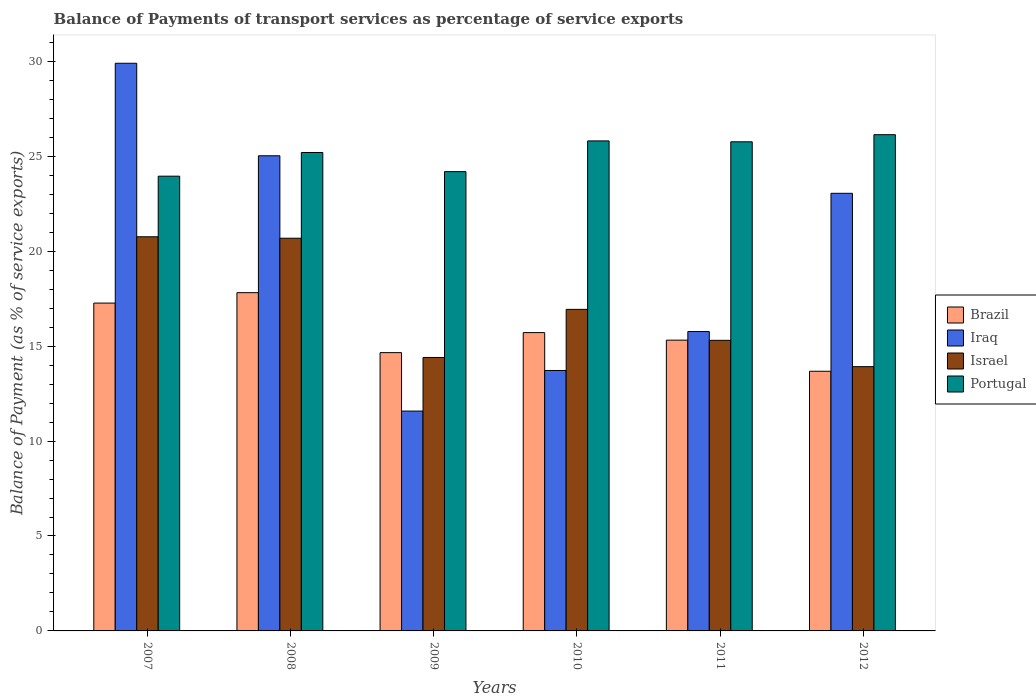Are the number of bars per tick equal to the number of legend labels?
Offer a terse response. Yes. What is the label of the 6th group of bars from the left?
Make the answer very short. 2012. What is the balance of payments of transport services in Portugal in 2008?
Offer a terse response. 25.2. Across all years, what is the maximum balance of payments of transport services in Portugal?
Provide a short and direct response. 26.14. Across all years, what is the minimum balance of payments of transport services in Portugal?
Provide a short and direct response. 23.95. In which year was the balance of payments of transport services in Brazil maximum?
Offer a very short reply. 2008. In which year was the balance of payments of transport services in Brazil minimum?
Your answer should be very brief. 2012. What is the total balance of payments of transport services in Brazil in the graph?
Your answer should be very brief. 94.45. What is the difference between the balance of payments of transport services in Portugal in 2009 and that in 2010?
Your answer should be very brief. -1.62. What is the difference between the balance of payments of transport services in Iraq in 2007 and the balance of payments of transport services in Israel in 2008?
Offer a terse response. 9.22. What is the average balance of payments of transport services in Israel per year?
Your response must be concise. 17. In the year 2007, what is the difference between the balance of payments of transport services in Iraq and balance of payments of transport services in Brazil?
Your answer should be very brief. 12.63. What is the ratio of the balance of payments of transport services in Brazil in 2009 to that in 2010?
Your answer should be very brief. 0.93. What is the difference between the highest and the second highest balance of payments of transport services in Brazil?
Your answer should be compact. 0.55. What is the difference between the highest and the lowest balance of payments of transport services in Brazil?
Your response must be concise. 4.14. Is the sum of the balance of payments of transport services in Israel in 2010 and 2012 greater than the maximum balance of payments of transport services in Portugal across all years?
Your answer should be compact. Yes. Is it the case that in every year, the sum of the balance of payments of transport services in Brazil and balance of payments of transport services in Israel is greater than the sum of balance of payments of transport services in Iraq and balance of payments of transport services in Portugal?
Your response must be concise. No. What does the 1st bar from the right in 2010 represents?
Keep it short and to the point. Portugal. Is it the case that in every year, the sum of the balance of payments of transport services in Iraq and balance of payments of transport services in Israel is greater than the balance of payments of transport services in Portugal?
Give a very brief answer. Yes. How many years are there in the graph?
Make the answer very short. 6. Does the graph contain any zero values?
Offer a very short reply. No. What is the title of the graph?
Make the answer very short. Balance of Payments of transport services as percentage of service exports. What is the label or title of the Y-axis?
Offer a terse response. Balance of Payment (as % of service exports). What is the Balance of Payment (as % of service exports) of Brazil in 2007?
Ensure brevity in your answer.  17.27. What is the Balance of Payment (as % of service exports) of Iraq in 2007?
Make the answer very short. 29.9. What is the Balance of Payment (as % of service exports) in Israel in 2007?
Your response must be concise. 20.76. What is the Balance of Payment (as % of service exports) of Portugal in 2007?
Your answer should be very brief. 23.95. What is the Balance of Payment (as % of service exports) in Brazil in 2008?
Offer a terse response. 17.82. What is the Balance of Payment (as % of service exports) of Iraq in 2008?
Make the answer very short. 25.03. What is the Balance of Payment (as % of service exports) of Israel in 2008?
Ensure brevity in your answer.  20.68. What is the Balance of Payment (as % of service exports) in Portugal in 2008?
Your answer should be compact. 25.2. What is the Balance of Payment (as % of service exports) of Brazil in 2009?
Provide a succinct answer. 14.66. What is the Balance of Payment (as % of service exports) of Iraq in 2009?
Offer a very short reply. 11.58. What is the Balance of Payment (as % of service exports) in Israel in 2009?
Provide a short and direct response. 14.4. What is the Balance of Payment (as % of service exports) in Portugal in 2009?
Keep it short and to the point. 24.19. What is the Balance of Payment (as % of service exports) in Brazil in 2010?
Keep it short and to the point. 15.71. What is the Balance of Payment (as % of service exports) in Iraq in 2010?
Your answer should be compact. 13.72. What is the Balance of Payment (as % of service exports) of Israel in 2010?
Offer a very short reply. 16.94. What is the Balance of Payment (as % of service exports) of Portugal in 2010?
Offer a very short reply. 25.81. What is the Balance of Payment (as % of service exports) of Brazil in 2011?
Offer a terse response. 15.32. What is the Balance of Payment (as % of service exports) in Iraq in 2011?
Keep it short and to the point. 15.77. What is the Balance of Payment (as % of service exports) of Israel in 2011?
Provide a succinct answer. 15.31. What is the Balance of Payment (as % of service exports) in Portugal in 2011?
Ensure brevity in your answer.  25.76. What is the Balance of Payment (as % of service exports) of Brazil in 2012?
Provide a succinct answer. 13.68. What is the Balance of Payment (as % of service exports) in Iraq in 2012?
Make the answer very short. 23.05. What is the Balance of Payment (as % of service exports) of Israel in 2012?
Offer a very short reply. 13.92. What is the Balance of Payment (as % of service exports) of Portugal in 2012?
Make the answer very short. 26.14. Across all years, what is the maximum Balance of Payment (as % of service exports) of Brazil?
Provide a short and direct response. 17.82. Across all years, what is the maximum Balance of Payment (as % of service exports) in Iraq?
Provide a succinct answer. 29.9. Across all years, what is the maximum Balance of Payment (as % of service exports) in Israel?
Offer a terse response. 20.76. Across all years, what is the maximum Balance of Payment (as % of service exports) in Portugal?
Ensure brevity in your answer.  26.14. Across all years, what is the minimum Balance of Payment (as % of service exports) in Brazil?
Keep it short and to the point. 13.68. Across all years, what is the minimum Balance of Payment (as % of service exports) in Iraq?
Your response must be concise. 11.58. Across all years, what is the minimum Balance of Payment (as % of service exports) of Israel?
Offer a terse response. 13.92. Across all years, what is the minimum Balance of Payment (as % of service exports) in Portugal?
Provide a succinct answer. 23.95. What is the total Balance of Payment (as % of service exports) of Brazil in the graph?
Provide a succinct answer. 94.45. What is the total Balance of Payment (as % of service exports) of Iraq in the graph?
Ensure brevity in your answer.  119.04. What is the total Balance of Payment (as % of service exports) of Israel in the graph?
Provide a succinct answer. 102.01. What is the total Balance of Payment (as % of service exports) of Portugal in the graph?
Ensure brevity in your answer.  151.05. What is the difference between the Balance of Payment (as % of service exports) in Brazil in 2007 and that in 2008?
Your answer should be compact. -0.55. What is the difference between the Balance of Payment (as % of service exports) in Iraq in 2007 and that in 2008?
Your response must be concise. 4.87. What is the difference between the Balance of Payment (as % of service exports) of Israel in 2007 and that in 2008?
Provide a succinct answer. 0.08. What is the difference between the Balance of Payment (as % of service exports) of Portugal in 2007 and that in 2008?
Ensure brevity in your answer.  -1.25. What is the difference between the Balance of Payment (as % of service exports) in Brazil in 2007 and that in 2009?
Provide a succinct answer. 2.61. What is the difference between the Balance of Payment (as % of service exports) of Iraq in 2007 and that in 2009?
Your response must be concise. 18.32. What is the difference between the Balance of Payment (as % of service exports) in Israel in 2007 and that in 2009?
Provide a succinct answer. 6.36. What is the difference between the Balance of Payment (as % of service exports) of Portugal in 2007 and that in 2009?
Provide a short and direct response. -0.24. What is the difference between the Balance of Payment (as % of service exports) of Brazil in 2007 and that in 2010?
Provide a short and direct response. 1.56. What is the difference between the Balance of Payment (as % of service exports) in Iraq in 2007 and that in 2010?
Offer a terse response. 16.18. What is the difference between the Balance of Payment (as % of service exports) of Israel in 2007 and that in 2010?
Give a very brief answer. 3.82. What is the difference between the Balance of Payment (as % of service exports) of Portugal in 2007 and that in 2010?
Ensure brevity in your answer.  -1.86. What is the difference between the Balance of Payment (as % of service exports) of Brazil in 2007 and that in 2011?
Provide a succinct answer. 1.95. What is the difference between the Balance of Payment (as % of service exports) in Iraq in 2007 and that in 2011?
Provide a short and direct response. 14.13. What is the difference between the Balance of Payment (as % of service exports) in Israel in 2007 and that in 2011?
Make the answer very short. 5.45. What is the difference between the Balance of Payment (as % of service exports) in Portugal in 2007 and that in 2011?
Ensure brevity in your answer.  -1.81. What is the difference between the Balance of Payment (as % of service exports) in Brazil in 2007 and that in 2012?
Your response must be concise. 3.59. What is the difference between the Balance of Payment (as % of service exports) in Iraq in 2007 and that in 2012?
Offer a very short reply. 6.85. What is the difference between the Balance of Payment (as % of service exports) in Israel in 2007 and that in 2012?
Give a very brief answer. 6.84. What is the difference between the Balance of Payment (as % of service exports) in Portugal in 2007 and that in 2012?
Your answer should be compact. -2.19. What is the difference between the Balance of Payment (as % of service exports) in Brazil in 2008 and that in 2009?
Offer a terse response. 3.16. What is the difference between the Balance of Payment (as % of service exports) in Iraq in 2008 and that in 2009?
Make the answer very short. 13.45. What is the difference between the Balance of Payment (as % of service exports) in Israel in 2008 and that in 2009?
Offer a very short reply. 6.28. What is the difference between the Balance of Payment (as % of service exports) in Portugal in 2008 and that in 2009?
Offer a very short reply. 1.01. What is the difference between the Balance of Payment (as % of service exports) of Brazil in 2008 and that in 2010?
Keep it short and to the point. 2.1. What is the difference between the Balance of Payment (as % of service exports) of Iraq in 2008 and that in 2010?
Make the answer very short. 11.31. What is the difference between the Balance of Payment (as % of service exports) in Israel in 2008 and that in 2010?
Ensure brevity in your answer.  3.75. What is the difference between the Balance of Payment (as % of service exports) of Portugal in 2008 and that in 2010?
Your answer should be very brief. -0.61. What is the difference between the Balance of Payment (as % of service exports) in Brazil in 2008 and that in 2011?
Provide a short and direct response. 2.5. What is the difference between the Balance of Payment (as % of service exports) of Iraq in 2008 and that in 2011?
Your answer should be compact. 9.26. What is the difference between the Balance of Payment (as % of service exports) of Israel in 2008 and that in 2011?
Offer a very short reply. 5.38. What is the difference between the Balance of Payment (as % of service exports) in Portugal in 2008 and that in 2011?
Ensure brevity in your answer.  -0.56. What is the difference between the Balance of Payment (as % of service exports) in Brazil in 2008 and that in 2012?
Make the answer very short. 4.14. What is the difference between the Balance of Payment (as % of service exports) of Iraq in 2008 and that in 2012?
Offer a terse response. 1.98. What is the difference between the Balance of Payment (as % of service exports) in Israel in 2008 and that in 2012?
Keep it short and to the point. 6.76. What is the difference between the Balance of Payment (as % of service exports) of Portugal in 2008 and that in 2012?
Your response must be concise. -0.94. What is the difference between the Balance of Payment (as % of service exports) of Brazil in 2009 and that in 2010?
Make the answer very short. -1.05. What is the difference between the Balance of Payment (as % of service exports) in Iraq in 2009 and that in 2010?
Keep it short and to the point. -2.14. What is the difference between the Balance of Payment (as % of service exports) in Israel in 2009 and that in 2010?
Your answer should be compact. -2.53. What is the difference between the Balance of Payment (as % of service exports) of Portugal in 2009 and that in 2010?
Provide a short and direct response. -1.62. What is the difference between the Balance of Payment (as % of service exports) of Brazil in 2009 and that in 2011?
Keep it short and to the point. -0.66. What is the difference between the Balance of Payment (as % of service exports) in Iraq in 2009 and that in 2011?
Make the answer very short. -4.19. What is the difference between the Balance of Payment (as % of service exports) in Israel in 2009 and that in 2011?
Your answer should be very brief. -0.9. What is the difference between the Balance of Payment (as % of service exports) of Portugal in 2009 and that in 2011?
Your answer should be very brief. -1.57. What is the difference between the Balance of Payment (as % of service exports) of Brazil in 2009 and that in 2012?
Make the answer very short. 0.98. What is the difference between the Balance of Payment (as % of service exports) of Iraq in 2009 and that in 2012?
Ensure brevity in your answer.  -11.47. What is the difference between the Balance of Payment (as % of service exports) of Israel in 2009 and that in 2012?
Your response must be concise. 0.48. What is the difference between the Balance of Payment (as % of service exports) of Portugal in 2009 and that in 2012?
Your answer should be compact. -1.95. What is the difference between the Balance of Payment (as % of service exports) of Brazil in 2010 and that in 2011?
Keep it short and to the point. 0.4. What is the difference between the Balance of Payment (as % of service exports) of Iraq in 2010 and that in 2011?
Your response must be concise. -2.05. What is the difference between the Balance of Payment (as % of service exports) in Israel in 2010 and that in 2011?
Ensure brevity in your answer.  1.63. What is the difference between the Balance of Payment (as % of service exports) in Portugal in 2010 and that in 2011?
Offer a very short reply. 0.05. What is the difference between the Balance of Payment (as % of service exports) in Brazil in 2010 and that in 2012?
Your response must be concise. 2.04. What is the difference between the Balance of Payment (as % of service exports) in Iraq in 2010 and that in 2012?
Offer a very short reply. -9.33. What is the difference between the Balance of Payment (as % of service exports) in Israel in 2010 and that in 2012?
Offer a terse response. 3.02. What is the difference between the Balance of Payment (as % of service exports) in Portugal in 2010 and that in 2012?
Keep it short and to the point. -0.33. What is the difference between the Balance of Payment (as % of service exports) of Brazil in 2011 and that in 2012?
Offer a terse response. 1.64. What is the difference between the Balance of Payment (as % of service exports) in Iraq in 2011 and that in 2012?
Give a very brief answer. -7.28. What is the difference between the Balance of Payment (as % of service exports) of Israel in 2011 and that in 2012?
Make the answer very short. 1.39. What is the difference between the Balance of Payment (as % of service exports) in Portugal in 2011 and that in 2012?
Your answer should be compact. -0.37. What is the difference between the Balance of Payment (as % of service exports) in Brazil in 2007 and the Balance of Payment (as % of service exports) in Iraq in 2008?
Offer a terse response. -7.76. What is the difference between the Balance of Payment (as % of service exports) of Brazil in 2007 and the Balance of Payment (as % of service exports) of Israel in 2008?
Give a very brief answer. -3.42. What is the difference between the Balance of Payment (as % of service exports) of Brazil in 2007 and the Balance of Payment (as % of service exports) of Portugal in 2008?
Your answer should be compact. -7.93. What is the difference between the Balance of Payment (as % of service exports) of Iraq in 2007 and the Balance of Payment (as % of service exports) of Israel in 2008?
Provide a succinct answer. 9.22. What is the difference between the Balance of Payment (as % of service exports) in Iraq in 2007 and the Balance of Payment (as % of service exports) in Portugal in 2008?
Give a very brief answer. 4.7. What is the difference between the Balance of Payment (as % of service exports) in Israel in 2007 and the Balance of Payment (as % of service exports) in Portugal in 2008?
Make the answer very short. -4.44. What is the difference between the Balance of Payment (as % of service exports) in Brazil in 2007 and the Balance of Payment (as % of service exports) in Iraq in 2009?
Your response must be concise. 5.69. What is the difference between the Balance of Payment (as % of service exports) of Brazil in 2007 and the Balance of Payment (as % of service exports) of Israel in 2009?
Provide a short and direct response. 2.87. What is the difference between the Balance of Payment (as % of service exports) of Brazil in 2007 and the Balance of Payment (as % of service exports) of Portugal in 2009?
Provide a succinct answer. -6.92. What is the difference between the Balance of Payment (as % of service exports) of Iraq in 2007 and the Balance of Payment (as % of service exports) of Israel in 2009?
Your answer should be very brief. 15.5. What is the difference between the Balance of Payment (as % of service exports) of Iraq in 2007 and the Balance of Payment (as % of service exports) of Portugal in 2009?
Give a very brief answer. 5.71. What is the difference between the Balance of Payment (as % of service exports) of Israel in 2007 and the Balance of Payment (as % of service exports) of Portugal in 2009?
Offer a terse response. -3.43. What is the difference between the Balance of Payment (as % of service exports) in Brazil in 2007 and the Balance of Payment (as % of service exports) in Iraq in 2010?
Your response must be concise. 3.55. What is the difference between the Balance of Payment (as % of service exports) of Brazil in 2007 and the Balance of Payment (as % of service exports) of Israel in 2010?
Your answer should be very brief. 0.33. What is the difference between the Balance of Payment (as % of service exports) of Brazil in 2007 and the Balance of Payment (as % of service exports) of Portugal in 2010?
Ensure brevity in your answer.  -8.54. What is the difference between the Balance of Payment (as % of service exports) of Iraq in 2007 and the Balance of Payment (as % of service exports) of Israel in 2010?
Keep it short and to the point. 12.96. What is the difference between the Balance of Payment (as % of service exports) of Iraq in 2007 and the Balance of Payment (as % of service exports) of Portugal in 2010?
Provide a short and direct response. 4.09. What is the difference between the Balance of Payment (as % of service exports) of Israel in 2007 and the Balance of Payment (as % of service exports) of Portugal in 2010?
Offer a very short reply. -5.05. What is the difference between the Balance of Payment (as % of service exports) of Brazil in 2007 and the Balance of Payment (as % of service exports) of Iraq in 2011?
Your answer should be very brief. 1.5. What is the difference between the Balance of Payment (as % of service exports) of Brazil in 2007 and the Balance of Payment (as % of service exports) of Israel in 2011?
Offer a very short reply. 1.96. What is the difference between the Balance of Payment (as % of service exports) of Brazil in 2007 and the Balance of Payment (as % of service exports) of Portugal in 2011?
Your answer should be very brief. -8.49. What is the difference between the Balance of Payment (as % of service exports) of Iraq in 2007 and the Balance of Payment (as % of service exports) of Israel in 2011?
Provide a short and direct response. 14.59. What is the difference between the Balance of Payment (as % of service exports) in Iraq in 2007 and the Balance of Payment (as % of service exports) in Portugal in 2011?
Provide a succinct answer. 4.14. What is the difference between the Balance of Payment (as % of service exports) in Israel in 2007 and the Balance of Payment (as % of service exports) in Portugal in 2011?
Provide a succinct answer. -5. What is the difference between the Balance of Payment (as % of service exports) in Brazil in 2007 and the Balance of Payment (as % of service exports) in Iraq in 2012?
Your answer should be very brief. -5.78. What is the difference between the Balance of Payment (as % of service exports) of Brazil in 2007 and the Balance of Payment (as % of service exports) of Israel in 2012?
Provide a succinct answer. 3.35. What is the difference between the Balance of Payment (as % of service exports) in Brazil in 2007 and the Balance of Payment (as % of service exports) in Portugal in 2012?
Ensure brevity in your answer.  -8.87. What is the difference between the Balance of Payment (as % of service exports) of Iraq in 2007 and the Balance of Payment (as % of service exports) of Israel in 2012?
Ensure brevity in your answer.  15.98. What is the difference between the Balance of Payment (as % of service exports) in Iraq in 2007 and the Balance of Payment (as % of service exports) in Portugal in 2012?
Ensure brevity in your answer.  3.76. What is the difference between the Balance of Payment (as % of service exports) in Israel in 2007 and the Balance of Payment (as % of service exports) in Portugal in 2012?
Make the answer very short. -5.38. What is the difference between the Balance of Payment (as % of service exports) of Brazil in 2008 and the Balance of Payment (as % of service exports) of Iraq in 2009?
Give a very brief answer. 6.24. What is the difference between the Balance of Payment (as % of service exports) of Brazil in 2008 and the Balance of Payment (as % of service exports) of Israel in 2009?
Provide a succinct answer. 3.41. What is the difference between the Balance of Payment (as % of service exports) of Brazil in 2008 and the Balance of Payment (as % of service exports) of Portugal in 2009?
Keep it short and to the point. -6.37. What is the difference between the Balance of Payment (as % of service exports) of Iraq in 2008 and the Balance of Payment (as % of service exports) of Israel in 2009?
Provide a short and direct response. 10.62. What is the difference between the Balance of Payment (as % of service exports) in Iraq in 2008 and the Balance of Payment (as % of service exports) in Portugal in 2009?
Offer a very short reply. 0.84. What is the difference between the Balance of Payment (as % of service exports) in Israel in 2008 and the Balance of Payment (as % of service exports) in Portugal in 2009?
Provide a succinct answer. -3.51. What is the difference between the Balance of Payment (as % of service exports) of Brazil in 2008 and the Balance of Payment (as % of service exports) of Iraq in 2010?
Keep it short and to the point. 4.1. What is the difference between the Balance of Payment (as % of service exports) of Brazil in 2008 and the Balance of Payment (as % of service exports) of Israel in 2010?
Provide a succinct answer. 0.88. What is the difference between the Balance of Payment (as % of service exports) in Brazil in 2008 and the Balance of Payment (as % of service exports) in Portugal in 2010?
Offer a terse response. -7.99. What is the difference between the Balance of Payment (as % of service exports) of Iraq in 2008 and the Balance of Payment (as % of service exports) of Israel in 2010?
Provide a succinct answer. 8.09. What is the difference between the Balance of Payment (as % of service exports) of Iraq in 2008 and the Balance of Payment (as % of service exports) of Portugal in 2010?
Give a very brief answer. -0.78. What is the difference between the Balance of Payment (as % of service exports) in Israel in 2008 and the Balance of Payment (as % of service exports) in Portugal in 2010?
Give a very brief answer. -5.13. What is the difference between the Balance of Payment (as % of service exports) of Brazil in 2008 and the Balance of Payment (as % of service exports) of Iraq in 2011?
Provide a short and direct response. 2.05. What is the difference between the Balance of Payment (as % of service exports) in Brazil in 2008 and the Balance of Payment (as % of service exports) in Israel in 2011?
Ensure brevity in your answer.  2.51. What is the difference between the Balance of Payment (as % of service exports) in Brazil in 2008 and the Balance of Payment (as % of service exports) in Portugal in 2011?
Ensure brevity in your answer.  -7.95. What is the difference between the Balance of Payment (as % of service exports) of Iraq in 2008 and the Balance of Payment (as % of service exports) of Israel in 2011?
Offer a very short reply. 9.72. What is the difference between the Balance of Payment (as % of service exports) of Iraq in 2008 and the Balance of Payment (as % of service exports) of Portugal in 2011?
Your answer should be very brief. -0.74. What is the difference between the Balance of Payment (as % of service exports) in Israel in 2008 and the Balance of Payment (as % of service exports) in Portugal in 2011?
Your response must be concise. -5.08. What is the difference between the Balance of Payment (as % of service exports) in Brazil in 2008 and the Balance of Payment (as % of service exports) in Iraq in 2012?
Provide a succinct answer. -5.23. What is the difference between the Balance of Payment (as % of service exports) in Brazil in 2008 and the Balance of Payment (as % of service exports) in Israel in 2012?
Make the answer very short. 3.9. What is the difference between the Balance of Payment (as % of service exports) in Brazil in 2008 and the Balance of Payment (as % of service exports) in Portugal in 2012?
Your answer should be very brief. -8.32. What is the difference between the Balance of Payment (as % of service exports) in Iraq in 2008 and the Balance of Payment (as % of service exports) in Israel in 2012?
Offer a very short reply. 11.11. What is the difference between the Balance of Payment (as % of service exports) in Iraq in 2008 and the Balance of Payment (as % of service exports) in Portugal in 2012?
Offer a very short reply. -1.11. What is the difference between the Balance of Payment (as % of service exports) of Israel in 2008 and the Balance of Payment (as % of service exports) of Portugal in 2012?
Your answer should be very brief. -5.45. What is the difference between the Balance of Payment (as % of service exports) of Brazil in 2009 and the Balance of Payment (as % of service exports) of Iraq in 2010?
Give a very brief answer. 0.94. What is the difference between the Balance of Payment (as % of service exports) in Brazil in 2009 and the Balance of Payment (as % of service exports) in Israel in 2010?
Ensure brevity in your answer.  -2.28. What is the difference between the Balance of Payment (as % of service exports) in Brazil in 2009 and the Balance of Payment (as % of service exports) in Portugal in 2010?
Keep it short and to the point. -11.15. What is the difference between the Balance of Payment (as % of service exports) in Iraq in 2009 and the Balance of Payment (as % of service exports) in Israel in 2010?
Your response must be concise. -5.36. What is the difference between the Balance of Payment (as % of service exports) in Iraq in 2009 and the Balance of Payment (as % of service exports) in Portugal in 2010?
Ensure brevity in your answer.  -14.23. What is the difference between the Balance of Payment (as % of service exports) in Israel in 2009 and the Balance of Payment (as % of service exports) in Portugal in 2010?
Keep it short and to the point. -11.41. What is the difference between the Balance of Payment (as % of service exports) in Brazil in 2009 and the Balance of Payment (as % of service exports) in Iraq in 2011?
Give a very brief answer. -1.11. What is the difference between the Balance of Payment (as % of service exports) in Brazil in 2009 and the Balance of Payment (as % of service exports) in Israel in 2011?
Offer a very short reply. -0.65. What is the difference between the Balance of Payment (as % of service exports) in Brazil in 2009 and the Balance of Payment (as % of service exports) in Portugal in 2011?
Provide a short and direct response. -11.1. What is the difference between the Balance of Payment (as % of service exports) in Iraq in 2009 and the Balance of Payment (as % of service exports) in Israel in 2011?
Your response must be concise. -3.73. What is the difference between the Balance of Payment (as % of service exports) of Iraq in 2009 and the Balance of Payment (as % of service exports) of Portugal in 2011?
Offer a terse response. -14.18. What is the difference between the Balance of Payment (as % of service exports) of Israel in 2009 and the Balance of Payment (as % of service exports) of Portugal in 2011?
Ensure brevity in your answer.  -11.36. What is the difference between the Balance of Payment (as % of service exports) of Brazil in 2009 and the Balance of Payment (as % of service exports) of Iraq in 2012?
Offer a very short reply. -8.39. What is the difference between the Balance of Payment (as % of service exports) in Brazil in 2009 and the Balance of Payment (as % of service exports) in Israel in 2012?
Offer a terse response. 0.74. What is the difference between the Balance of Payment (as % of service exports) of Brazil in 2009 and the Balance of Payment (as % of service exports) of Portugal in 2012?
Your answer should be very brief. -11.48. What is the difference between the Balance of Payment (as % of service exports) in Iraq in 2009 and the Balance of Payment (as % of service exports) in Israel in 2012?
Keep it short and to the point. -2.34. What is the difference between the Balance of Payment (as % of service exports) in Iraq in 2009 and the Balance of Payment (as % of service exports) in Portugal in 2012?
Your response must be concise. -14.56. What is the difference between the Balance of Payment (as % of service exports) of Israel in 2009 and the Balance of Payment (as % of service exports) of Portugal in 2012?
Give a very brief answer. -11.74. What is the difference between the Balance of Payment (as % of service exports) in Brazil in 2010 and the Balance of Payment (as % of service exports) in Iraq in 2011?
Give a very brief answer. -0.06. What is the difference between the Balance of Payment (as % of service exports) in Brazil in 2010 and the Balance of Payment (as % of service exports) in Israel in 2011?
Your answer should be compact. 0.41. What is the difference between the Balance of Payment (as % of service exports) in Brazil in 2010 and the Balance of Payment (as % of service exports) in Portugal in 2011?
Offer a terse response. -10.05. What is the difference between the Balance of Payment (as % of service exports) in Iraq in 2010 and the Balance of Payment (as % of service exports) in Israel in 2011?
Make the answer very short. -1.59. What is the difference between the Balance of Payment (as % of service exports) of Iraq in 2010 and the Balance of Payment (as % of service exports) of Portugal in 2011?
Your response must be concise. -12.05. What is the difference between the Balance of Payment (as % of service exports) of Israel in 2010 and the Balance of Payment (as % of service exports) of Portugal in 2011?
Your response must be concise. -8.83. What is the difference between the Balance of Payment (as % of service exports) of Brazil in 2010 and the Balance of Payment (as % of service exports) of Iraq in 2012?
Your answer should be compact. -7.34. What is the difference between the Balance of Payment (as % of service exports) in Brazil in 2010 and the Balance of Payment (as % of service exports) in Israel in 2012?
Offer a very short reply. 1.79. What is the difference between the Balance of Payment (as % of service exports) of Brazil in 2010 and the Balance of Payment (as % of service exports) of Portugal in 2012?
Provide a succinct answer. -10.43. What is the difference between the Balance of Payment (as % of service exports) of Iraq in 2010 and the Balance of Payment (as % of service exports) of Israel in 2012?
Ensure brevity in your answer.  -0.2. What is the difference between the Balance of Payment (as % of service exports) of Iraq in 2010 and the Balance of Payment (as % of service exports) of Portugal in 2012?
Ensure brevity in your answer.  -12.42. What is the difference between the Balance of Payment (as % of service exports) in Israel in 2010 and the Balance of Payment (as % of service exports) in Portugal in 2012?
Ensure brevity in your answer.  -9.2. What is the difference between the Balance of Payment (as % of service exports) of Brazil in 2011 and the Balance of Payment (as % of service exports) of Iraq in 2012?
Make the answer very short. -7.73. What is the difference between the Balance of Payment (as % of service exports) in Brazil in 2011 and the Balance of Payment (as % of service exports) in Israel in 2012?
Provide a succinct answer. 1.4. What is the difference between the Balance of Payment (as % of service exports) in Brazil in 2011 and the Balance of Payment (as % of service exports) in Portugal in 2012?
Make the answer very short. -10.82. What is the difference between the Balance of Payment (as % of service exports) of Iraq in 2011 and the Balance of Payment (as % of service exports) of Israel in 2012?
Give a very brief answer. 1.85. What is the difference between the Balance of Payment (as % of service exports) in Iraq in 2011 and the Balance of Payment (as % of service exports) in Portugal in 2012?
Your answer should be very brief. -10.37. What is the difference between the Balance of Payment (as % of service exports) in Israel in 2011 and the Balance of Payment (as % of service exports) in Portugal in 2012?
Provide a short and direct response. -10.83. What is the average Balance of Payment (as % of service exports) in Brazil per year?
Your response must be concise. 15.74. What is the average Balance of Payment (as % of service exports) in Iraq per year?
Provide a succinct answer. 19.84. What is the average Balance of Payment (as % of service exports) in Israel per year?
Offer a very short reply. 17. What is the average Balance of Payment (as % of service exports) in Portugal per year?
Your answer should be compact. 25.18. In the year 2007, what is the difference between the Balance of Payment (as % of service exports) of Brazil and Balance of Payment (as % of service exports) of Iraq?
Provide a short and direct response. -12.63. In the year 2007, what is the difference between the Balance of Payment (as % of service exports) of Brazil and Balance of Payment (as % of service exports) of Israel?
Offer a terse response. -3.49. In the year 2007, what is the difference between the Balance of Payment (as % of service exports) in Brazil and Balance of Payment (as % of service exports) in Portugal?
Your response must be concise. -6.68. In the year 2007, what is the difference between the Balance of Payment (as % of service exports) in Iraq and Balance of Payment (as % of service exports) in Israel?
Your answer should be compact. 9.14. In the year 2007, what is the difference between the Balance of Payment (as % of service exports) of Iraq and Balance of Payment (as % of service exports) of Portugal?
Ensure brevity in your answer.  5.95. In the year 2007, what is the difference between the Balance of Payment (as % of service exports) in Israel and Balance of Payment (as % of service exports) in Portugal?
Your answer should be compact. -3.19. In the year 2008, what is the difference between the Balance of Payment (as % of service exports) of Brazil and Balance of Payment (as % of service exports) of Iraq?
Your answer should be very brief. -7.21. In the year 2008, what is the difference between the Balance of Payment (as % of service exports) in Brazil and Balance of Payment (as % of service exports) in Israel?
Offer a terse response. -2.87. In the year 2008, what is the difference between the Balance of Payment (as % of service exports) in Brazil and Balance of Payment (as % of service exports) in Portugal?
Provide a succinct answer. -7.38. In the year 2008, what is the difference between the Balance of Payment (as % of service exports) of Iraq and Balance of Payment (as % of service exports) of Israel?
Provide a short and direct response. 4.34. In the year 2008, what is the difference between the Balance of Payment (as % of service exports) of Iraq and Balance of Payment (as % of service exports) of Portugal?
Keep it short and to the point. -0.17. In the year 2008, what is the difference between the Balance of Payment (as % of service exports) of Israel and Balance of Payment (as % of service exports) of Portugal?
Provide a short and direct response. -4.52. In the year 2009, what is the difference between the Balance of Payment (as % of service exports) in Brazil and Balance of Payment (as % of service exports) in Iraq?
Offer a very short reply. 3.08. In the year 2009, what is the difference between the Balance of Payment (as % of service exports) of Brazil and Balance of Payment (as % of service exports) of Israel?
Keep it short and to the point. 0.26. In the year 2009, what is the difference between the Balance of Payment (as % of service exports) of Brazil and Balance of Payment (as % of service exports) of Portugal?
Provide a succinct answer. -9.53. In the year 2009, what is the difference between the Balance of Payment (as % of service exports) in Iraq and Balance of Payment (as % of service exports) in Israel?
Your response must be concise. -2.82. In the year 2009, what is the difference between the Balance of Payment (as % of service exports) of Iraq and Balance of Payment (as % of service exports) of Portugal?
Ensure brevity in your answer.  -12.61. In the year 2009, what is the difference between the Balance of Payment (as % of service exports) of Israel and Balance of Payment (as % of service exports) of Portugal?
Offer a very short reply. -9.79. In the year 2010, what is the difference between the Balance of Payment (as % of service exports) in Brazil and Balance of Payment (as % of service exports) in Iraq?
Your answer should be very brief. 2. In the year 2010, what is the difference between the Balance of Payment (as % of service exports) in Brazil and Balance of Payment (as % of service exports) in Israel?
Your answer should be compact. -1.22. In the year 2010, what is the difference between the Balance of Payment (as % of service exports) of Brazil and Balance of Payment (as % of service exports) of Portugal?
Your response must be concise. -10.1. In the year 2010, what is the difference between the Balance of Payment (as % of service exports) in Iraq and Balance of Payment (as % of service exports) in Israel?
Provide a succinct answer. -3.22. In the year 2010, what is the difference between the Balance of Payment (as % of service exports) of Iraq and Balance of Payment (as % of service exports) of Portugal?
Your answer should be compact. -12.09. In the year 2010, what is the difference between the Balance of Payment (as % of service exports) in Israel and Balance of Payment (as % of service exports) in Portugal?
Offer a very short reply. -8.87. In the year 2011, what is the difference between the Balance of Payment (as % of service exports) in Brazil and Balance of Payment (as % of service exports) in Iraq?
Offer a terse response. -0.45. In the year 2011, what is the difference between the Balance of Payment (as % of service exports) of Brazil and Balance of Payment (as % of service exports) of Israel?
Keep it short and to the point. 0.01. In the year 2011, what is the difference between the Balance of Payment (as % of service exports) of Brazil and Balance of Payment (as % of service exports) of Portugal?
Your response must be concise. -10.45. In the year 2011, what is the difference between the Balance of Payment (as % of service exports) of Iraq and Balance of Payment (as % of service exports) of Israel?
Offer a very short reply. 0.46. In the year 2011, what is the difference between the Balance of Payment (as % of service exports) of Iraq and Balance of Payment (as % of service exports) of Portugal?
Offer a terse response. -9.99. In the year 2011, what is the difference between the Balance of Payment (as % of service exports) in Israel and Balance of Payment (as % of service exports) in Portugal?
Ensure brevity in your answer.  -10.46. In the year 2012, what is the difference between the Balance of Payment (as % of service exports) in Brazil and Balance of Payment (as % of service exports) in Iraq?
Keep it short and to the point. -9.37. In the year 2012, what is the difference between the Balance of Payment (as % of service exports) in Brazil and Balance of Payment (as % of service exports) in Israel?
Make the answer very short. -0.24. In the year 2012, what is the difference between the Balance of Payment (as % of service exports) of Brazil and Balance of Payment (as % of service exports) of Portugal?
Keep it short and to the point. -12.46. In the year 2012, what is the difference between the Balance of Payment (as % of service exports) of Iraq and Balance of Payment (as % of service exports) of Israel?
Give a very brief answer. 9.13. In the year 2012, what is the difference between the Balance of Payment (as % of service exports) in Iraq and Balance of Payment (as % of service exports) in Portugal?
Keep it short and to the point. -3.09. In the year 2012, what is the difference between the Balance of Payment (as % of service exports) of Israel and Balance of Payment (as % of service exports) of Portugal?
Offer a very short reply. -12.22. What is the ratio of the Balance of Payment (as % of service exports) of Brazil in 2007 to that in 2008?
Keep it short and to the point. 0.97. What is the ratio of the Balance of Payment (as % of service exports) of Iraq in 2007 to that in 2008?
Make the answer very short. 1.19. What is the ratio of the Balance of Payment (as % of service exports) of Portugal in 2007 to that in 2008?
Give a very brief answer. 0.95. What is the ratio of the Balance of Payment (as % of service exports) in Brazil in 2007 to that in 2009?
Give a very brief answer. 1.18. What is the ratio of the Balance of Payment (as % of service exports) of Iraq in 2007 to that in 2009?
Give a very brief answer. 2.58. What is the ratio of the Balance of Payment (as % of service exports) of Israel in 2007 to that in 2009?
Make the answer very short. 1.44. What is the ratio of the Balance of Payment (as % of service exports) in Brazil in 2007 to that in 2010?
Your response must be concise. 1.1. What is the ratio of the Balance of Payment (as % of service exports) in Iraq in 2007 to that in 2010?
Provide a succinct answer. 2.18. What is the ratio of the Balance of Payment (as % of service exports) in Israel in 2007 to that in 2010?
Provide a short and direct response. 1.23. What is the ratio of the Balance of Payment (as % of service exports) in Portugal in 2007 to that in 2010?
Offer a terse response. 0.93. What is the ratio of the Balance of Payment (as % of service exports) of Brazil in 2007 to that in 2011?
Offer a very short reply. 1.13. What is the ratio of the Balance of Payment (as % of service exports) of Iraq in 2007 to that in 2011?
Offer a very short reply. 1.9. What is the ratio of the Balance of Payment (as % of service exports) in Israel in 2007 to that in 2011?
Offer a very short reply. 1.36. What is the ratio of the Balance of Payment (as % of service exports) in Portugal in 2007 to that in 2011?
Offer a terse response. 0.93. What is the ratio of the Balance of Payment (as % of service exports) of Brazil in 2007 to that in 2012?
Make the answer very short. 1.26. What is the ratio of the Balance of Payment (as % of service exports) of Iraq in 2007 to that in 2012?
Your answer should be very brief. 1.3. What is the ratio of the Balance of Payment (as % of service exports) in Israel in 2007 to that in 2012?
Provide a short and direct response. 1.49. What is the ratio of the Balance of Payment (as % of service exports) of Portugal in 2007 to that in 2012?
Your answer should be compact. 0.92. What is the ratio of the Balance of Payment (as % of service exports) of Brazil in 2008 to that in 2009?
Provide a succinct answer. 1.22. What is the ratio of the Balance of Payment (as % of service exports) of Iraq in 2008 to that in 2009?
Make the answer very short. 2.16. What is the ratio of the Balance of Payment (as % of service exports) of Israel in 2008 to that in 2009?
Your response must be concise. 1.44. What is the ratio of the Balance of Payment (as % of service exports) in Portugal in 2008 to that in 2009?
Provide a succinct answer. 1.04. What is the ratio of the Balance of Payment (as % of service exports) of Brazil in 2008 to that in 2010?
Your response must be concise. 1.13. What is the ratio of the Balance of Payment (as % of service exports) in Iraq in 2008 to that in 2010?
Make the answer very short. 1.82. What is the ratio of the Balance of Payment (as % of service exports) of Israel in 2008 to that in 2010?
Your answer should be very brief. 1.22. What is the ratio of the Balance of Payment (as % of service exports) in Portugal in 2008 to that in 2010?
Make the answer very short. 0.98. What is the ratio of the Balance of Payment (as % of service exports) in Brazil in 2008 to that in 2011?
Ensure brevity in your answer.  1.16. What is the ratio of the Balance of Payment (as % of service exports) of Iraq in 2008 to that in 2011?
Your answer should be very brief. 1.59. What is the ratio of the Balance of Payment (as % of service exports) in Israel in 2008 to that in 2011?
Give a very brief answer. 1.35. What is the ratio of the Balance of Payment (as % of service exports) of Portugal in 2008 to that in 2011?
Ensure brevity in your answer.  0.98. What is the ratio of the Balance of Payment (as % of service exports) of Brazil in 2008 to that in 2012?
Your answer should be compact. 1.3. What is the ratio of the Balance of Payment (as % of service exports) in Iraq in 2008 to that in 2012?
Offer a terse response. 1.09. What is the ratio of the Balance of Payment (as % of service exports) in Israel in 2008 to that in 2012?
Make the answer very short. 1.49. What is the ratio of the Balance of Payment (as % of service exports) in Portugal in 2008 to that in 2012?
Provide a succinct answer. 0.96. What is the ratio of the Balance of Payment (as % of service exports) in Brazil in 2009 to that in 2010?
Provide a short and direct response. 0.93. What is the ratio of the Balance of Payment (as % of service exports) of Iraq in 2009 to that in 2010?
Make the answer very short. 0.84. What is the ratio of the Balance of Payment (as % of service exports) of Israel in 2009 to that in 2010?
Your answer should be compact. 0.85. What is the ratio of the Balance of Payment (as % of service exports) in Portugal in 2009 to that in 2010?
Your answer should be very brief. 0.94. What is the ratio of the Balance of Payment (as % of service exports) in Brazil in 2009 to that in 2011?
Your answer should be compact. 0.96. What is the ratio of the Balance of Payment (as % of service exports) in Iraq in 2009 to that in 2011?
Give a very brief answer. 0.73. What is the ratio of the Balance of Payment (as % of service exports) of Israel in 2009 to that in 2011?
Provide a succinct answer. 0.94. What is the ratio of the Balance of Payment (as % of service exports) of Portugal in 2009 to that in 2011?
Your answer should be compact. 0.94. What is the ratio of the Balance of Payment (as % of service exports) of Brazil in 2009 to that in 2012?
Your answer should be very brief. 1.07. What is the ratio of the Balance of Payment (as % of service exports) in Iraq in 2009 to that in 2012?
Provide a succinct answer. 0.5. What is the ratio of the Balance of Payment (as % of service exports) in Israel in 2009 to that in 2012?
Offer a very short reply. 1.03. What is the ratio of the Balance of Payment (as % of service exports) in Portugal in 2009 to that in 2012?
Ensure brevity in your answer.  0.93. What is the ratio of the Balance of Payment (as % of service exports) in Iraq in 2010 to that in 2011?
Your response must be concise. 0.87. What is the ratio of the Balance of Payment (as % of service exports) in Israel in 2010 to that in 2011?
Provide a short and direct response. 1.11. What is the ratio of the Balance of Payment (as % of service exports) in Brazil in 2010 to that in 2012?
Give a very brief answer. 1.15. What is the ratio of the Balance of Payment (as % of service exports) in Iraq in 2010 to that in 2012?
Offer a terse response. 0.6. What is the ratio of the Balance of Payment (as % of service exports) of Israel in 2010 to that in 2012?
Your answer should be very brief. 1.22. What is the ratio of the Balance of Payment (as % of service exports) in Portugal in 2010 to that in 2012?
Provide a succinct answer. 0.99. What is the ratio of the Balance of Payment (as % of service exports) in Brazil in 2011 to that in 2012?
Make the answer very short. 1.12. What is the ratio of the Balance of Payment (as % of service exports) in Iraq in 2011 to that in 2012?
Your response must be concise. 0.68. What is the ratio of the Balance of Payment (as % of service exports) of Israel in 2011 to that in 2012?
Provide a short and direct response. 1.1. What is the ratio of the Balance of Payment (as % of service exports) of Portugal in 2011 to that in 2012?
Offer a very short reply. 0.99. What is the difference between the highest and the second highest Balance of Payment (as % of service exports) in Brazil?
Offer a terse response. 0.55. What is the difference between the highest and the second highest Balance of Payment (as % of service exports) of Iraq?
Offer a very short reply. 4.87. What is the difference between the highest and the second highest Balance of Payment (as % of service exports) of Israel?
Offer a terse response. 0.08. What is the difference between the highest and the second highest Balance of Payment (as % of service exports) in Portugal?
Make the answer very short. 0.33. What is the difference between the highest and the lowest Balance of Payment (as % of service exports) of Brazil?
Your answer should be very brief. 4.14. What is the difference between the highest and the lowest Balance of Payment (as % of service exports) of Iraq?
Your response must be concise. 18.32. What is the difference between the highest and the lowest Balance of Payment (as % of service exports) in Israel?
Provide a short and direct response. 6.84. What is the difference between the highest and the lowest Balance of Payment (as % of service exports) in Portugal?
Provide a short and direct response. 2.19. 